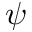Convert formula to latex. <formula><loc_0><loc_0><loc_500><loc_500>\psi</formula> 